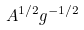Convert formula to latex. <formula><loc_0><loc_0><loc_500><loc_500>A ^ { 1 / 2 } g ^ { - 1 / 2 }</formula> 